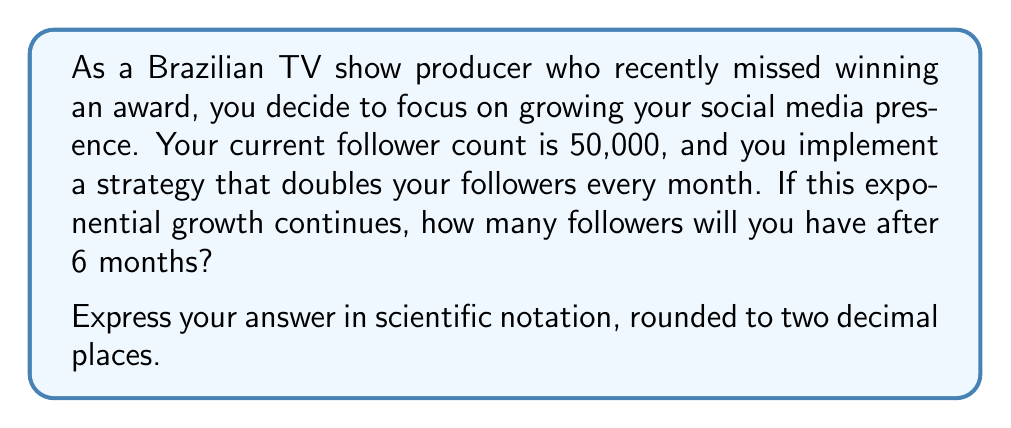Give your solution to this math problem. Let's approach this step-by-step:

1) We start with 50,000 followers.

2) The number of followers doubles every month, which means we multiply by 2 each month.

3) This can be expressed as an exponential function:
   $f(x) = 50000 \cdot 2^x$, where $x$ is the number of months.

4) We want to know the number of followers after 6 months, so we calculate $f(6)$:

   $f(6) = 50000 \cdot 2^6$

5) Let's compute this:
   $f(6) = 50000 \cdot 64$ (since $2^6 = 64$)
   
   $f(6) = 3,200,000$

6) To express this in scientific notation, we move the decimal point to have one non-zero digit before it:

   $3,200,000 = 3.2 \times 10^6$

Therefore, after 6 months of doubling each month, you would have $3.2 \times 10^6$ followers.
Answer: $3.20 \times 10^6$ followers 